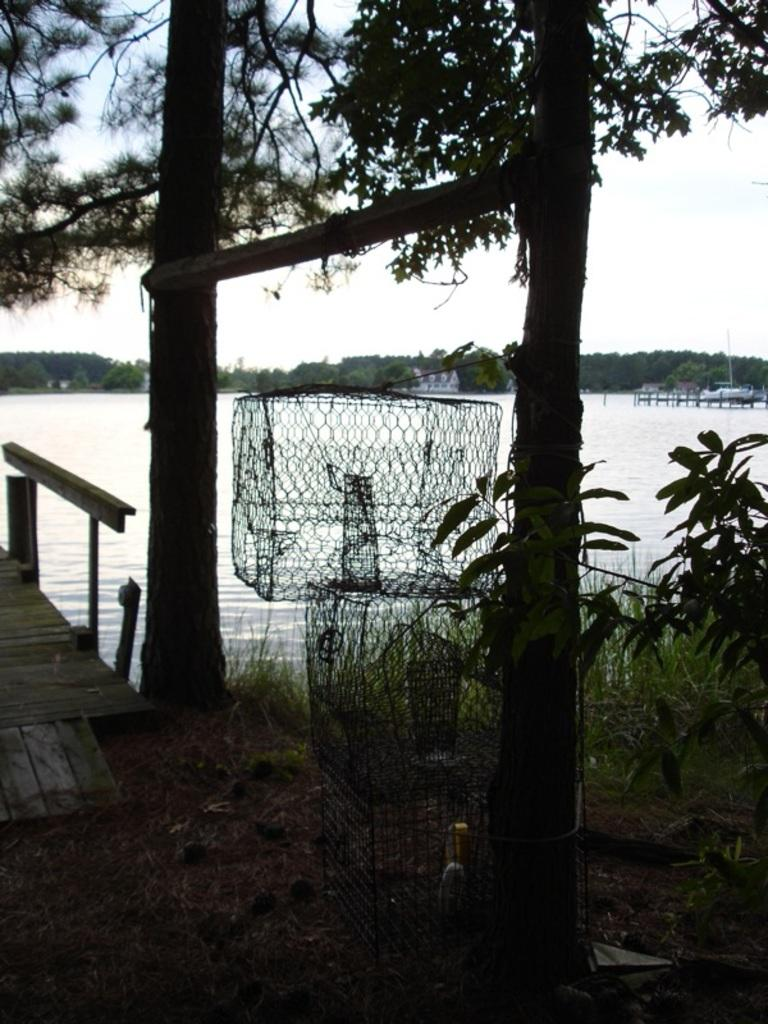What type of objects are present in the image that have a rectangular shape? There are net boxes in the image that have a rectangular shape. What type of vegetation can be seen in the image? There are trees in the image. What is located on the left side of the image? There is a wooden path on the left side of the image. What can be seen in the background of the image? The background of the image includes trees and a water body. Where is the grandmother sitting in the image? There is no grandmother present in the image. What type of scale can be seen in the image? There is no scale present in the image. 